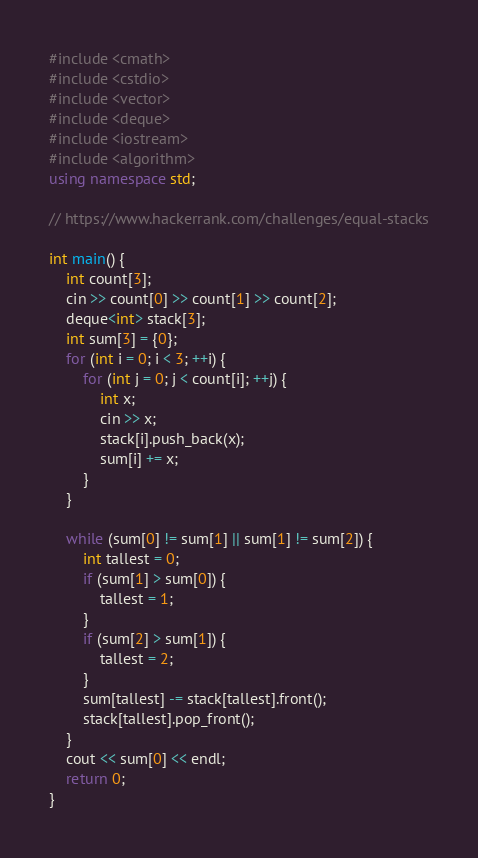<code> <loc_0><loc_0><loc_500><loc_500><_C++_>#include <cmath>
#include <cstdio>
#include <vector>
#include <deque>
#include <iostream>
#include <algorithm>
using namespace std;

// https://www.hackerrank.com/challenges/equal-stacks

int main() {
    int count[3];
    cin >> count[0] >> count[1] >> count[2];
    deque<int> stack[3];
    int sum[3] = {0};
    for (int i = 0; i < 3; ++i) {
        for (int j = 0; j < count[i]; ++j) {
            int x;
            cin >> x;
            stack[i].push_back(x);
            sum[i] += x;
        }
    }

    while (sum[0] != sum[1] || sum[1] != sum[2]) {
        int tallest = 0;
        if (sum[1] > sum[0]) {
            tallest = 1;
        }
        if (sum[2] > sum[1]) {
            tallest = 2;
        }
        sum[tallest] -= stack[tallest].front();
        stack[tallest].pop_front();
    }
    cout << sum[0] << endl;
    return 0;
}</code> 